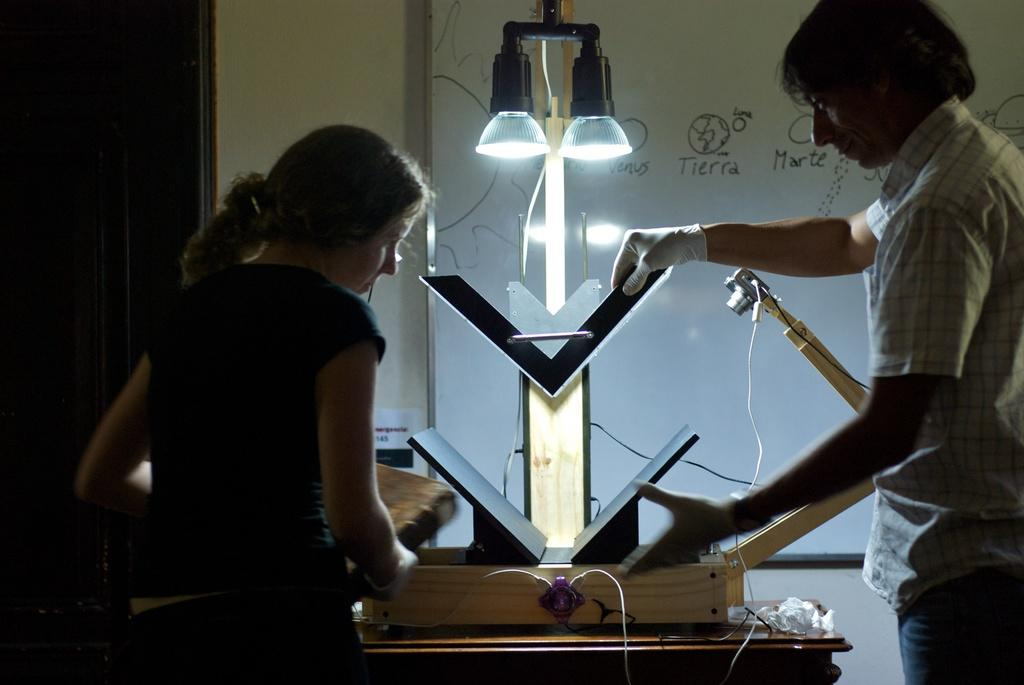What type of electronic object can be seen in the image? The electronic object present in the image is not specified. How many people are standing in the image? There is a man and a woman standing in the image. What is the purpose of the whiteboard in the image? The purpose of the whiteboard in the image is not specified. What is the background of the image? There is a wall in the image, which serves as the background. What type of bread is being used to write on the whiteboard in the image? There is no bread present in the image, and the whiteboard is not being written on with any bread. What channel is the man watching on the electronic object in the image? The type of electronic object and whether it is capable of displaying channels is not specified in the image. 